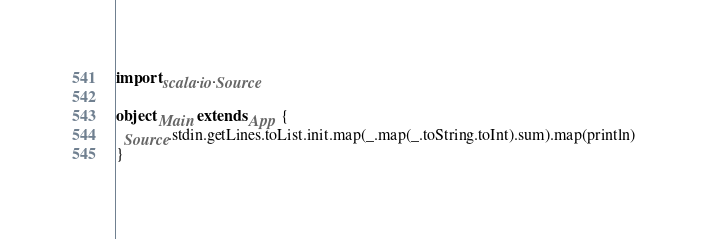<code> <loc_0><loc_0><loc_500><loc_500><_Scala_>import scala.io.Source

object Main extends App {
  Source.stdin.getLines.toList.init.map(_.map(_.toString.toInt).sum).map(println)
}</code> 